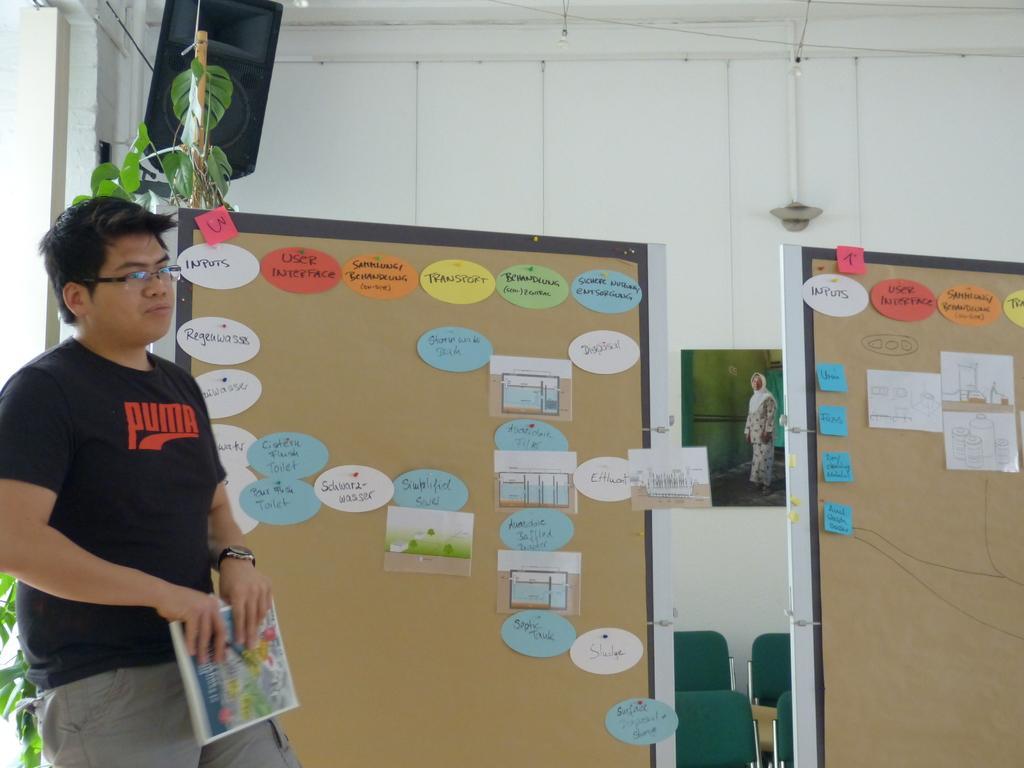Could you give a brief overview of what you see in this image? In this image we can see a man is standing, he is holding a book in the hands, beside there are boards and sticky notes on it, there is a plant, at the corner there is a speaker, there are chairs, there is a wall and a photo frame on it. 